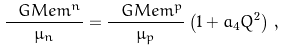Convert formula to latex. <formula><loc_0><loc_0><loc_500><loc_500>\frac { \ G M e m ^ { n } } { \mu _ { n } } = \frac { \ G M e m ^ { p } } { \mu _ { p } } \left ( 1 + a _ { 4 } Q ^ { 2 } \right ) \, ,</formula> 